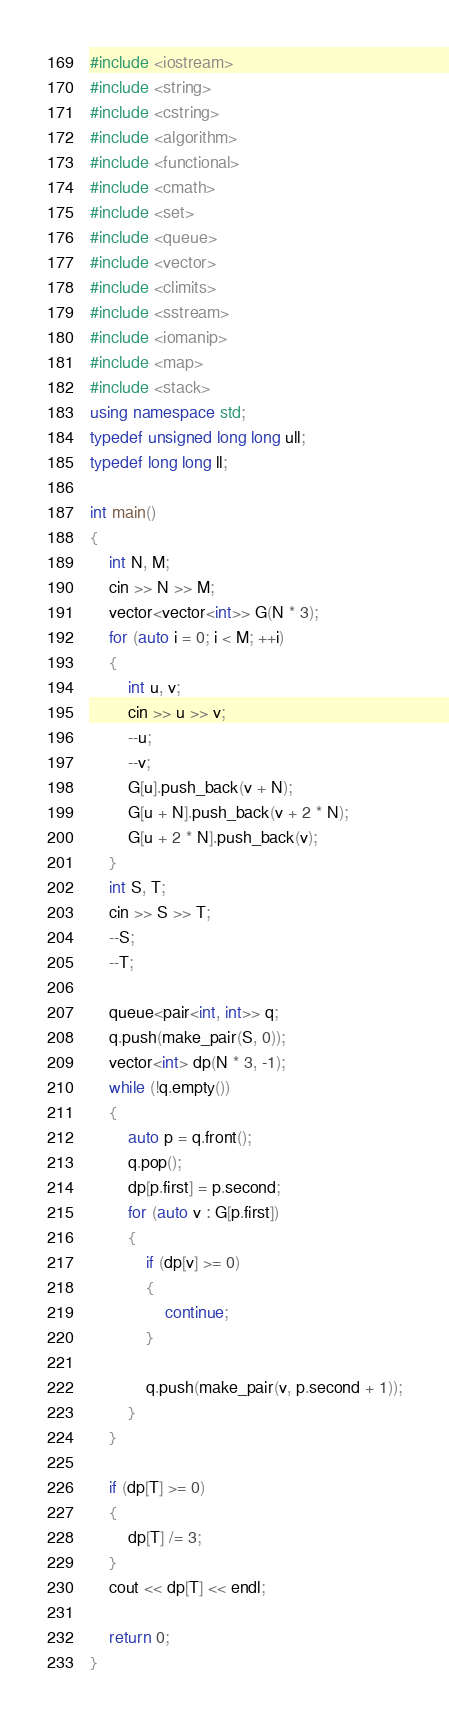Convert code to text. <code><loc_0><loc_0><loc_500><loc_500><_C++_>#include <iostream>
#include <string>
#include <cstring>
#include <algorithm>
#include <functional>
#include <cmath>
#include <set>
#include <queue>
#include <vector>
#include <climits>
#include <sstream>
#include <iomanip>
#include <map>
#include <stack>
using namespace std;
typedef unsigned long long ull;
typedef long long ll;

int main()
{
	int N, M;
	cin >> N >> M;
	vector<vector<int>> G(N * 3);
	for (auto i = 0; i < M; ++i)
	{
		int u, v;
		cin >> u >> v;
		--u;
		--v;
		G[u].push_back(v + N);
		G[u + N].push_back(v + 2 * N);
		G[u + 2 * N].push_back(v);
	}
	int S, T;
	cin >> S >> T;
	--S;
	--T;

	queue<pair<int, int>> q;
	q.push(make_pair(S, 0));
	vector<int> dp(N * 3, -1);
	while (!q.empty())
	{
		auto p = q.front();
		q.pop();
		dp[p.first] = p.second;
		for (auto v : G[p.first])
		{
			if (dp[v] >= 0)
			{
				continue;
			}

			q.push(make_pair(v, p.second + 1));
		}
	}

	if (dp[T] >= 0)
	{
		dp[T] /= 3;
	}
	cout << dp[T] << endl;

	return 0;
}</code> 